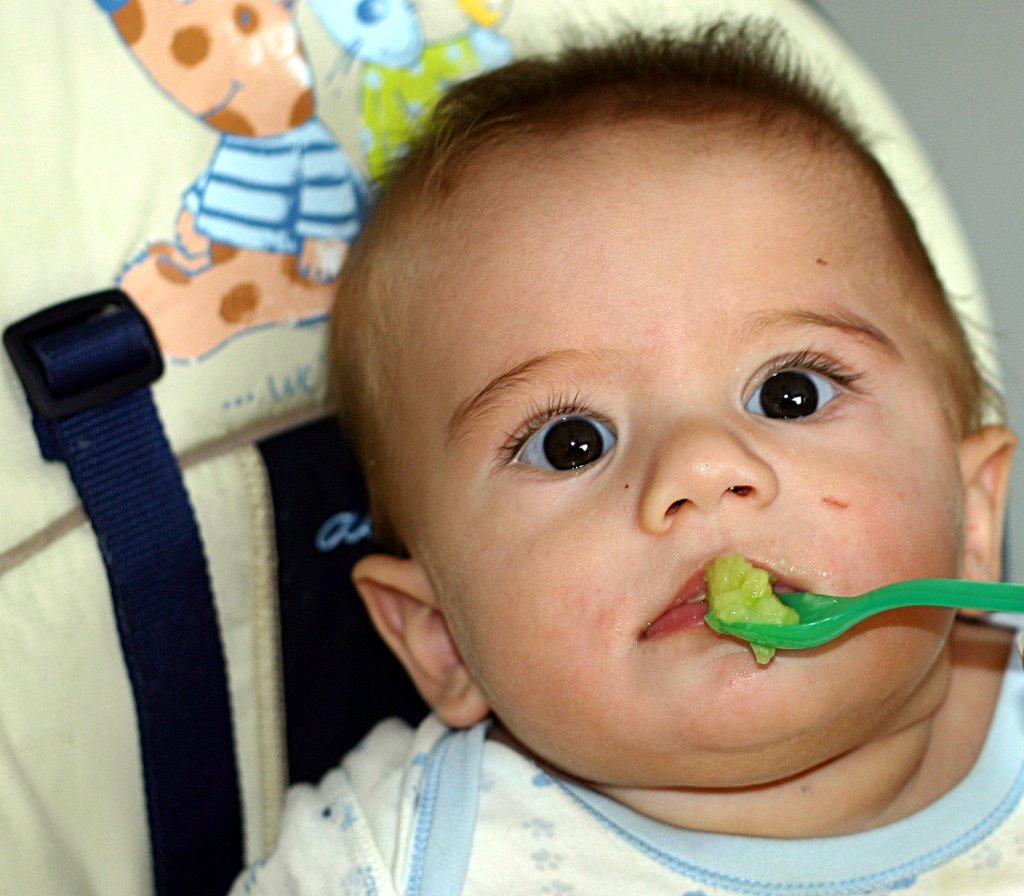Can you describe this image briefly? In this picture we can see a child, spoon, cloth and some objects. 